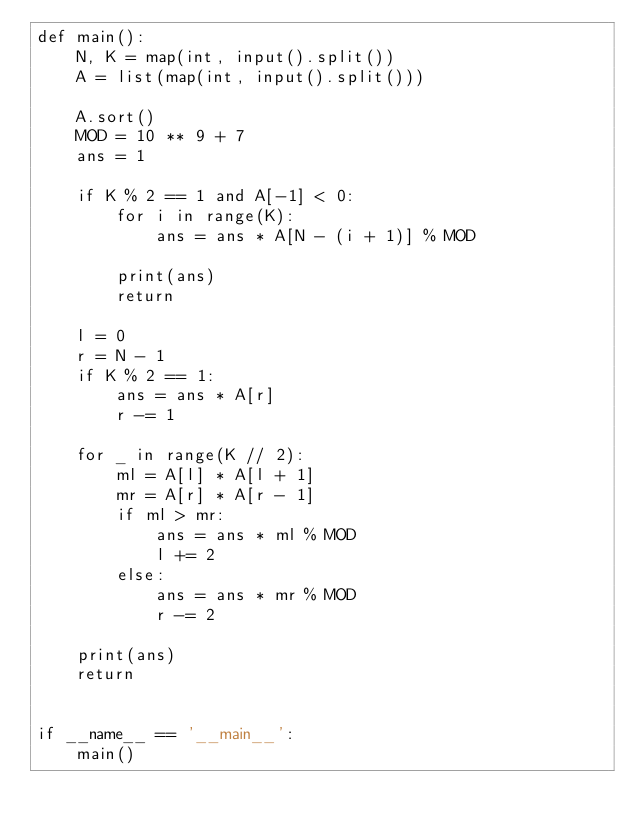Convert code to text. <code><loc_0><loc_0><loc_500><loc_500><_Python_>def main():
    N, K = map(int, input().split())
    A = list(map(int, input().split()))

    A.sort()
    MOD = 10 ** 9 + 7
    ans = 1

    if K % 2 == 1 and A[-1] < 0:
        for i in range(K):
            ans = ans * A[N - (i + 1)] % MOD

        print(ans)
        return

    l = 0
    r = N - 1
    if K % 2 == 1:
        ans = ans * A[r]
        r -= 1
    
    for _ in range(K // 2):
        ml = A[l] * A[l + 1]
        mr = A[r] * A[r - 1]
        if ml > mr:
            ans = ans * ml % MOD
            l += 2
        else:
            ans = ans * mr % MOD
            r -= 2

    print(ans)
    return


if __name__ == '__main__':
    main()
</code> 